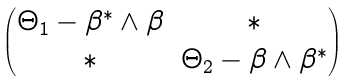<formula> <loc_0><loc_0><loc_500><loc_500>\begin{pmatrix} \Theta _ { 1 } - \beta ^ { * } \wedge \beta & \ast \\ \ast & \Theta _ { 2 } - \beta \wedge \beta ^ { * } \end{pmatrix}</formula> 